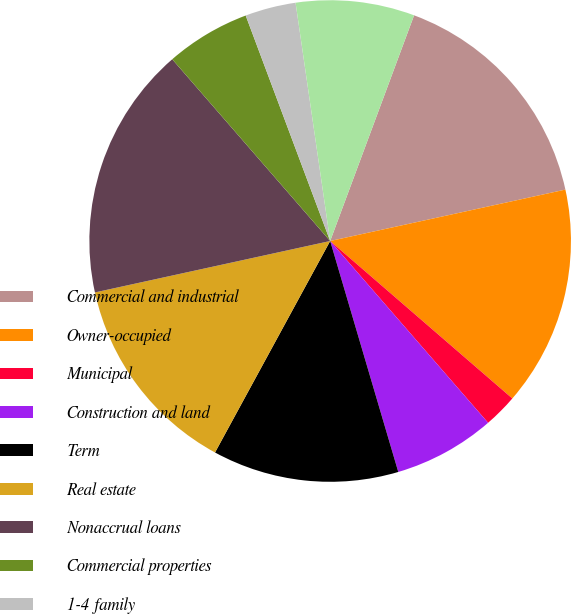<chart> <loc_0><loc_0><loc_500><loc_500><pie_chart><fcel>Commercial and industrial<fcel>Owner-occupied<fcel>Municipal<fcel>Construction and land<fcel>Term<fcel>Real estate<fcel>Nonaccrual loans<fcel>Commercial properties<fcel>1-4 family<fcel>Other real estate owned<nl><fcel>15.91%<fcel>14.77%<fcel>2.27%<fcel>6.82%<fcel>12.5%<fcel>13.64%<fcel>17.04%<fcel>5.68%<fcel>3.41%<fcel>7.96%<nl></chart> 